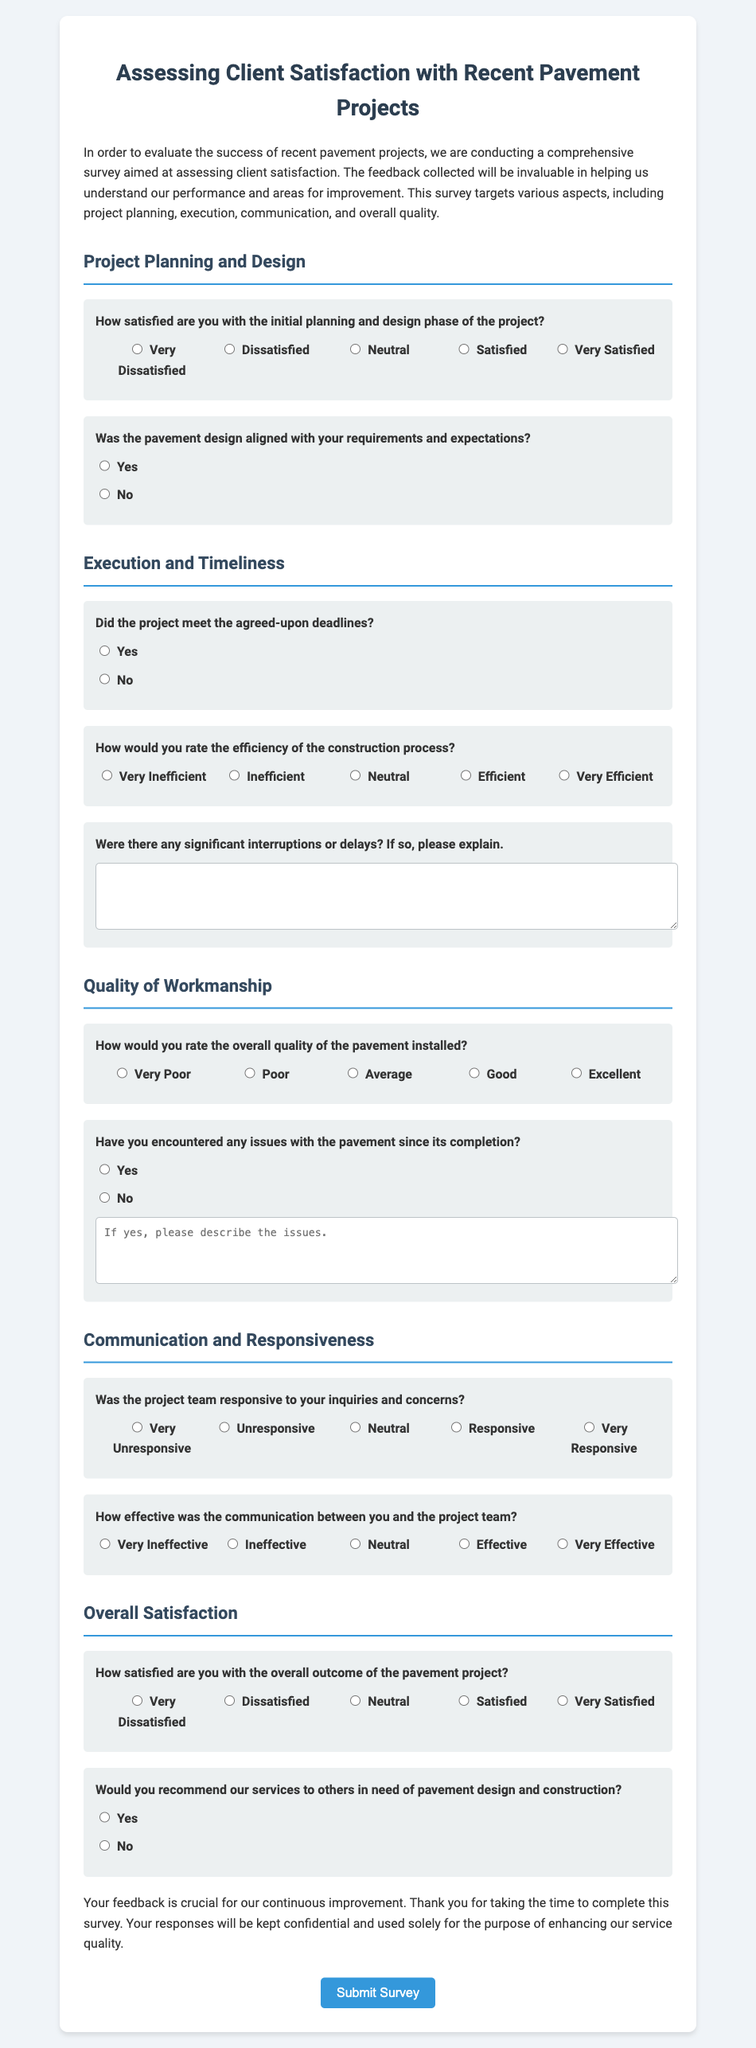What is the title of the survey? The title of the survey is presented prominently at the top of the document.
Answer: Assessing Client Satisfaction with Recent Pavement Projects How many sections are in the form? The form is divided into distinct sections that focus on different aspects of client satisfaction.
Answer: Four What is the highest rating option available for construction efficiency? The highest rating option for construction efficiency is clearly stated in the rating section.
Answer: Very Efficient Was the pavement design aligned with your requirements and expectations? This is a direct question included in the design section of the survey.
Answer: Yes What type of feedback does the survey aim to collect? The survey aims to gather feedback related to client satisfaction with various aspects of pavement projects.
Answer: Client satisfaction How many radio buttons are provided for rating overall satisfaction? The document lists a set of rating options for overall satisfaction, indicating a specific number of choices.
Answer: Five 